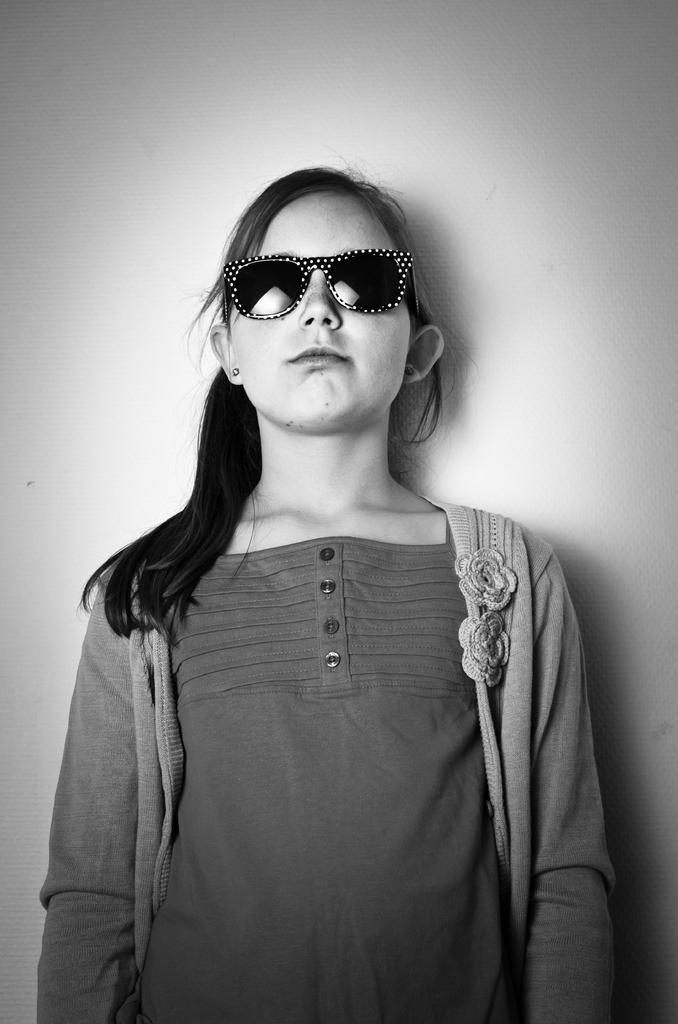Who is present in the image? There is a woman in the image. What is the woman doing in the image? The woman is standing in the image. What is the woman's facial expression in the image? The woman is smiling in the image. What can be seen behind the woman in the image? There is a wall behind the woman in the image. What color is the silver in the image? There is no silver present in the image. How many elbows can be seen in the image? The image only shows one person, so only one elbow can be seen. 